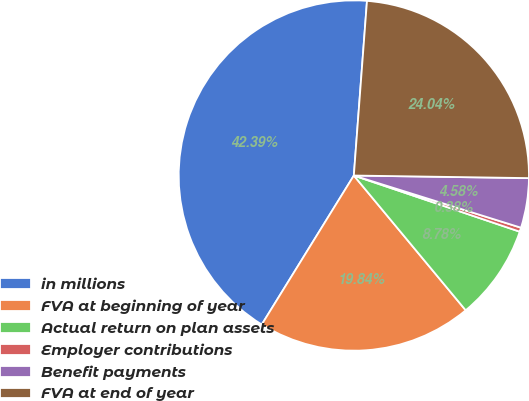Convert chart. <chart><loc_0><loc_0><loc_500><loc_500><pie_chart><fcel>in millions<fcel>FVA at beginning of year<fcel>Actual return on plan assets<fcel>Employer contributions<fcel>Benefit payments<fcel>FVA at end of year<nl><fcel>42.39%<fcel>19.84%<fcel>8.78%<fcel>0.38%<fcel>4.58%<fcel>24.04%<nl></chart> 